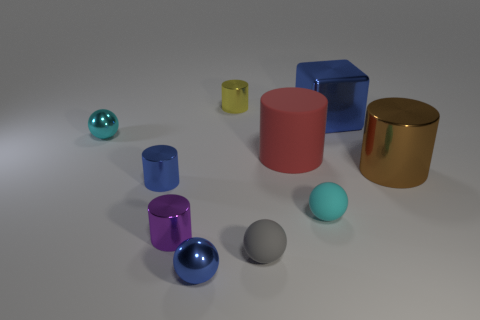What number of objects are either tiny metal things in front of the big blue object or small red cubes? In the image, there are a total of four objects that meet the given criteria. Specifically, there are three tiny metal spheres in front of the large blue cube and one small red cube present. 